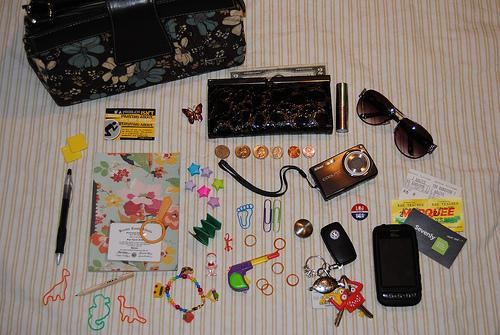Provide a short story that could connect all writing-related objects in the image. A writer, inspired by the sight of six multicolored plastic decorative stars, decided to use his black ink pen to jot down creative ideas in his writing journal, later to exchange those ideas with colleagues by using the stack of business cards found nearby. What kind of electronic devices are present in the image, and how many are there? There are 4 electronic devices: a digital camera, a remote for a car, a black smartphone, and a black automatic camera. What is the most valuable item on the bed based on its denomination?  The most valuable item on the bed is the two-dollar bill with dimensions (Width: 146, Height: 146). What are the two smallest items in the image, based on their size dimensions? The two smallest items are a black ink pen with dimensions (Width: 19, Height: 19), and two yellow plastic squares with dimensions (Width: 27, Height: 27). Identify and count the number of objects related to fashion accessories in the image. There are 7 fashion accessories: a pair of sunglasses, a beaded bracelet, brown tinted womans sunglasses, a black blue and white handbag, a black shiny womans wallet, loose change, and elastic band bracelets. List the objects that can be used for personal organization or storage in the image. A black blue and white handbag, a black shiny womans wallet, and a notebook can be used for personal organization or storage. What types of toy weapons are in the image and how many are there? There are two toy weapons: a multicolored toy gun and a toy rubber band gun. 